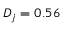<formula> <loc_0><loc_0><loc_500><loc_500>D _ { j } = 0 . 5 6</formula> 